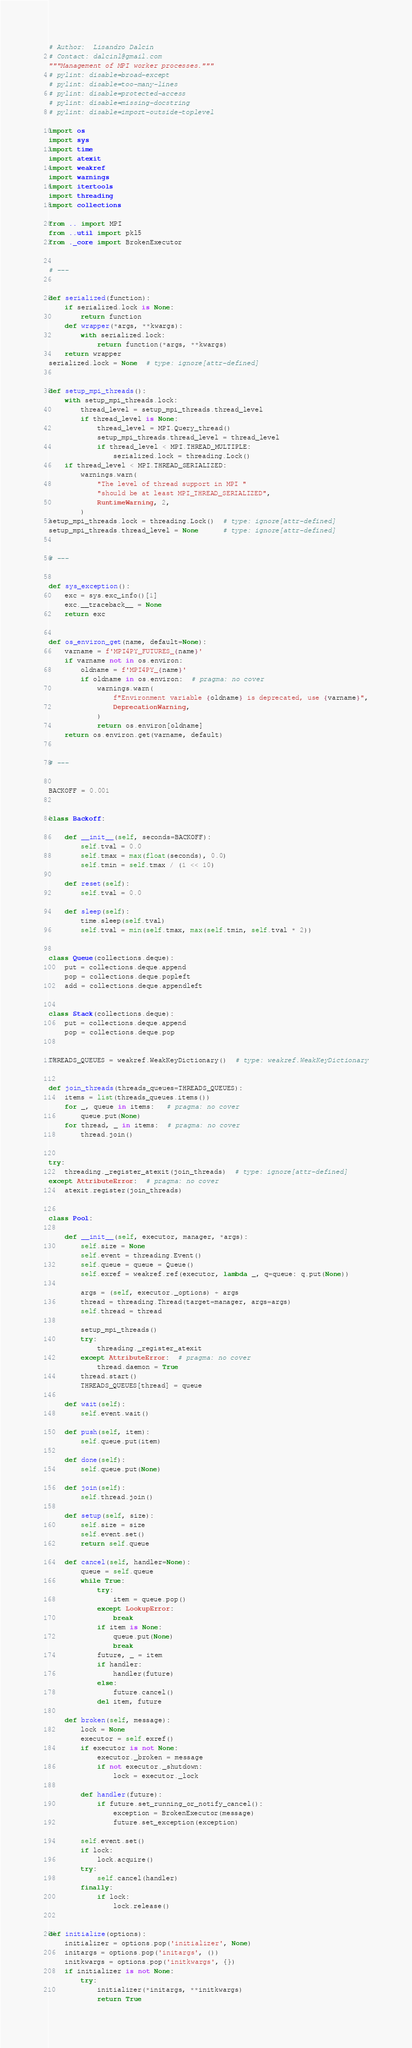<code> <loc_0><loc_0><loc_500><loc_500><_Python_># Author:  Lisandro Dalcin
# Contact: dalcinl@gmail.com
"""Management of MPI worker processes."""
# pylint: disable=broad-except
# pylint: disable=too-many-lines
# pylint: disable=protected-access
# pylint: disable=missing-docstring
# pylint: disable=import-outside-toplevel

import os
import sys
import time
import atexit
import weakref
import warnings
import itertools
import threading
import collections

from .. import MPI
from ..util import pkl5
from ._core import BrokenExecutor


# ---


def serialized(function):
    if serialized.lock is None:
        return function
    def wrapper(*args, **kwargs):
        with serialized.lock:
            return function(*args, **kwargs)
    return wrapper
serialized.lock = None  # type: ignore[attr-defined]


def setup_mpi_threads():
    with setup_mpi_threads.lock:
        thread_level = setup_mpi_threads.thread_level
        if thread_level is None:
            thread_level = MPI.Query_thread()
            setup_mpi_threads.thread_level = thread_level
            if thread_level < MPI.THREAD_MULTIPLE:
                serialized.lock = threading.Lock()
    if thread_level < MPI.THREAD_SERIALIZED:
        warnings.warn(
            "The level of thread support in MPI "
            "should be at least MPI_THREAD_SERIALIZED",
            RuntimeWarning, 2,
        )
setup_mpi_threads.lock = threading.Lock()  # type: ignore[attr-defined]
setup_mpi_threads.thread_level = None      # type: ignore[attr-defined]


# ---


def sys_exception():
    exc = sys.exc_info()[1]
    exc.__traceback__ = None
    return exc


def os_environ_get(name, default=None):
    varname = f'MPI4PY_FUTURES_{name}'
    if varname not in os.environ:
        oldname = f'MPI4PY_{name}'
        if oldname in os.environ:  # pragma: no cover
            warnings.warn(
                f"Environment variable {oldname} is deprecated, use {varname}",
                DeprecationWarning,
            )
            return os.environ[oldname]
    return os.environ.get(varname, default)


# ---


BACKOFF = 0.001


class Backoff:

    def __init__(self, seconds=BACKOFF):
        self.tval = 0.0
        self.tmax = max(float(seconds), 0.0)
        self.tmin = self.tmax / (1 << 10)

    def reset(self):
        self.tval = 0.0

    def sleep(self):
        time.sleep(self.tval)
        self.tval = min(self.tmax, max(self.tmin, self.tval * 2))


class Queue(collections.deque):
    put = collections.deque.append
    pop = collections.deque.popleft
    add = collections.deque.appendleft


class Stack(collections.deque):
    put = collections.deque.append
    pop = collections.deque.pop


THREADS_QUEUES = weakref.WeakKeyDictionary()  # type: weakref.WeakKeyDictionary


def join_threads(threads_queues=THREADS_QUEUES):
    items = list(threads_queues.items())
    for _, queue in items:   # pragma: no cover
        queue.put(None)
    for thread, _ in items:  # pragma: no cover
        thread.join()


try:
    threading._register_atexit(join_threads)  # type: ignore[attr-defined]
except AttributeError:  # pragma: no cover
    atexit.register(join_threads)


class Pool:

    def __init__(self, executor, manager, *args):
        self.size = None
        self.event = threading.Event()
        self.queue = queue = Queue()
        self.exref = weakref.ref(executor, lambda _, q=queue: q.put(None))

        args = (self, executor._options) + args
        thread = threading.Thread(target=manager, args=args)
        self.thread = thread

        setup_mpi_threads()
        try:
            threading._register_atexit
        except AttributeError:  # pragma: no cover
            thread.daemon = True
        thread.start()
        THREADS_QUEUES[thread] = queue

    def wait(self):
        self.event.wait()

    def push(self, item):
        self.queue.put(item)

    def done(self):
        self.queue.put(None)

    def join(self):
        self.thread.join()

    def setup(self, size):
        self.size = size
        self.event.set()
        return self.queue

    def cancel(self, handler=None):
        queue = self.queue
        while True:
            try:
                item = queue.pop()
            except LookupError:
                break
            if item is None:
                queue.put(None)
                break
            future, _ = item
            if handler:
                handler(future)
            else:
                future.cancel()
            del item, future

    def broken(self, message):
        lock = None
        executor = self.exref()
        if executor is not None:
            executor._broken = message
            if not executor._shutdown:
                lock = executor._lock

        def handler(future):
            if future.set_running_or_notify_cancel():
                exception = BrokenExecutor(message)
                future.set_exception(exception)

        self.event.set()
        if lock:
            lock.acquire()
        try:
            self.cancel(handler)
        finally:
            if lock:
                lock.release()


def initialize(options):
    initializer = options.pop('initializer', None)
    initargs = options.pop('initargs', ())
    initkwargs = options.pop('initkwargs', {})
    if initializer is not None:
        try:
            initializer(*initargs, **initkwargs)
            return True</code> 